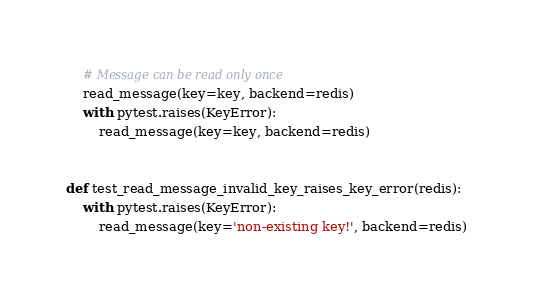Convert code to text. <code><loc_0><loc_0><loc_500><loc_500><_Python_>    # Message can be read only once
    read_message(key=key, backend=redis)
    with pytest.raises(KeyError):
        read_message(key=key, backend=redis)


def test_read_message_invalid_key_raises_key_error(redis):
    with pytest.raises(KeyError):
        read_message(key='non-existing key!', backend=redis)



</code> 